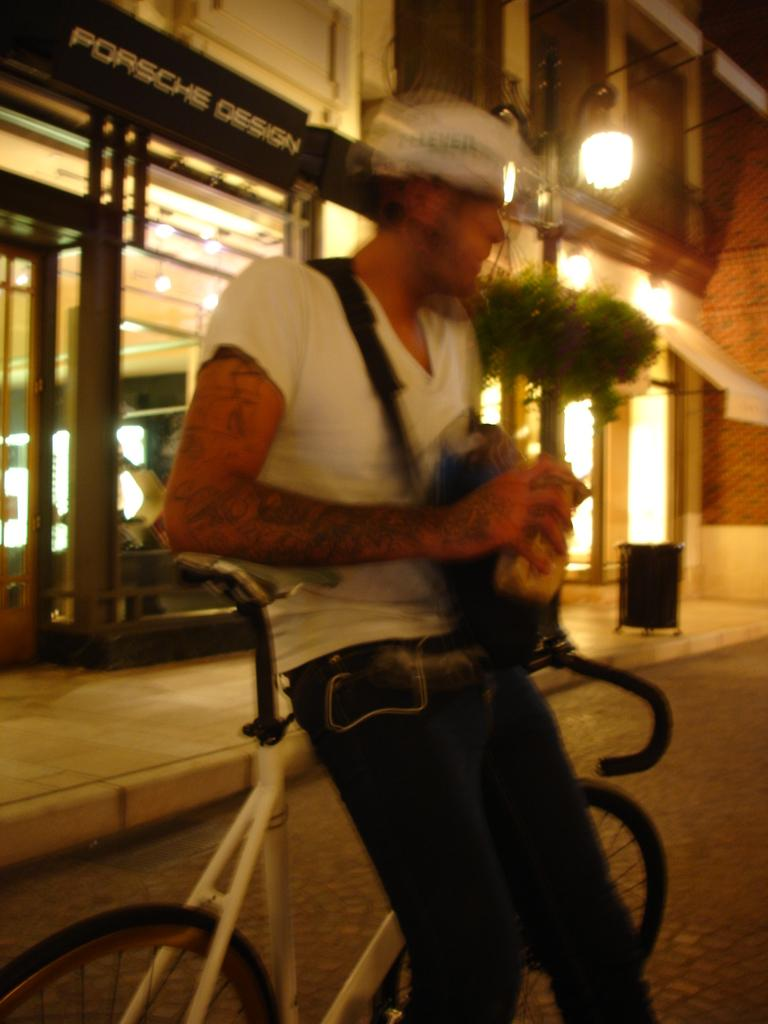Who is present in the image? There is a person in the image. What is the person wearing? The person is wearing a white shirt. What is the person doing in the image? The person is sitting on a bicycle. What can be seen in the background of the image? There is a store visible in the background of the image. What type of request is the person making at the airport in the image? There is no airport present in the image, and the person is not making any requests. 